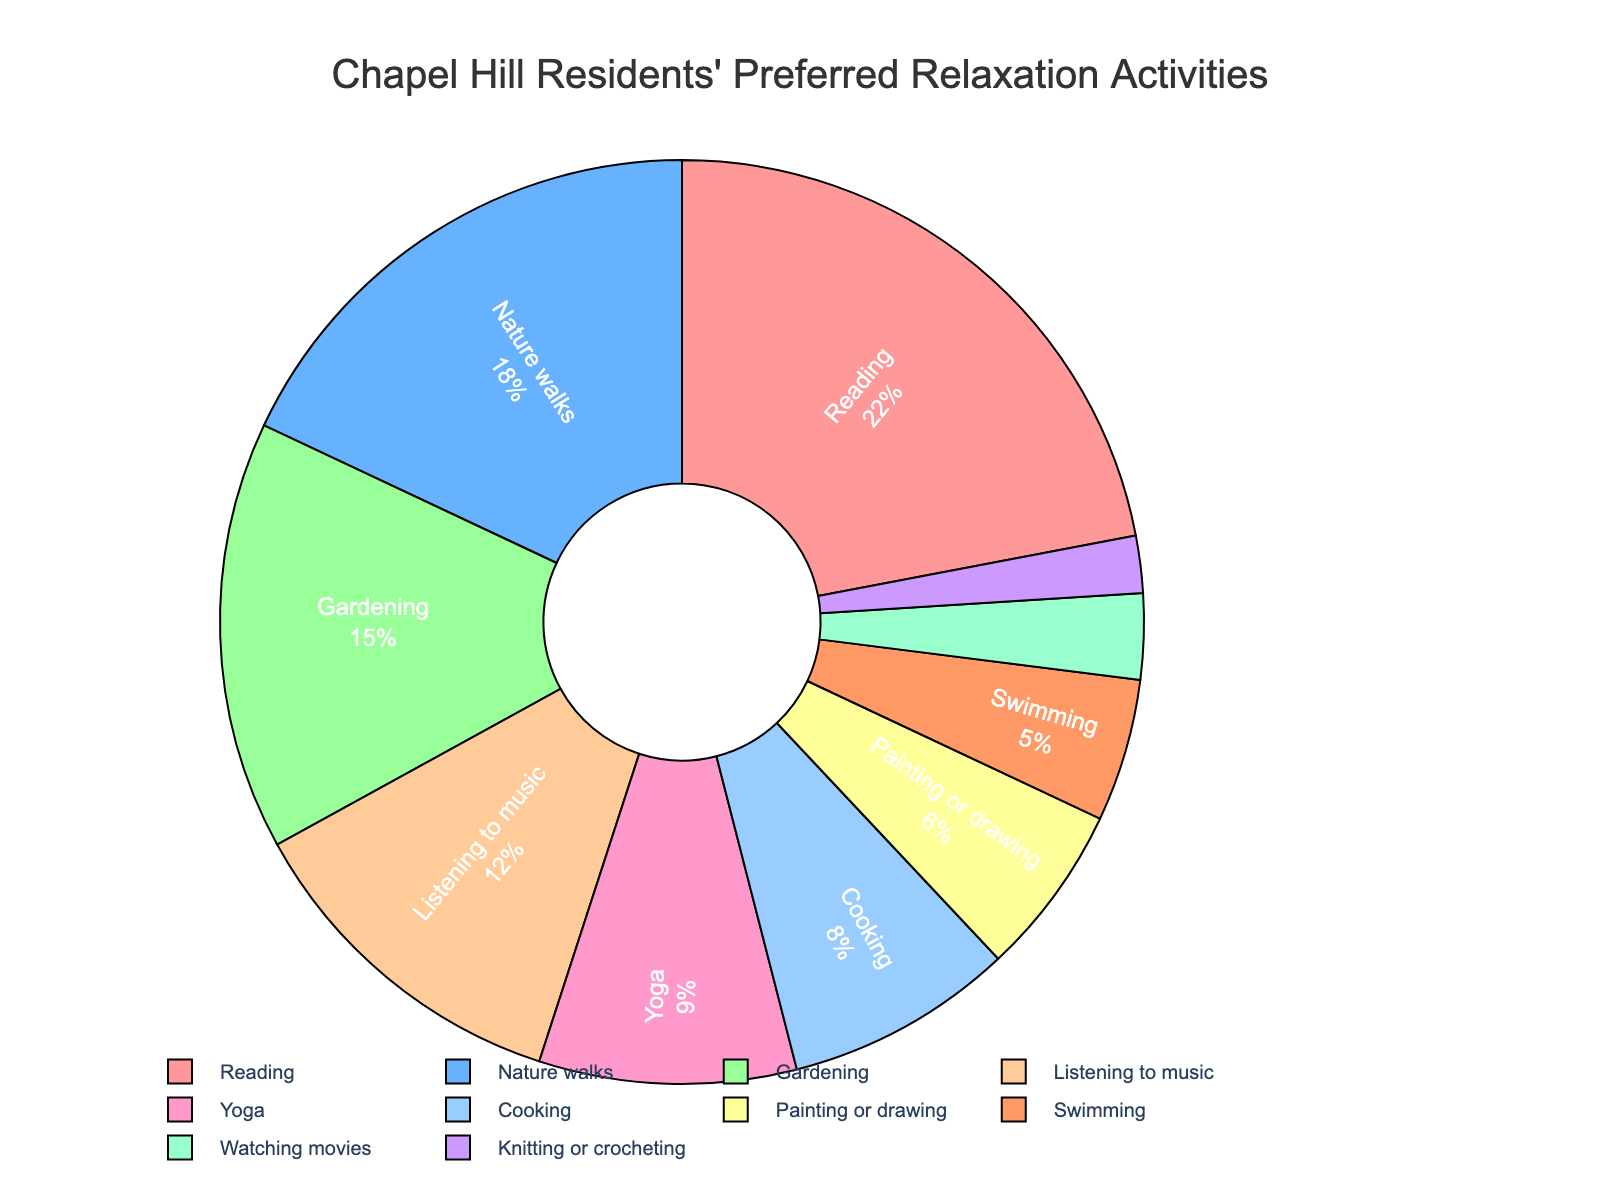Which activity is preferred by the highest percentage of Chapel Hill residents? By examining the pie chart, the activity with the largest slice represents the highest preference. According to the figure, reading has the largest slice.
Answer: Reading What is the total percentage of residents who prefer gardening or cooking? By adding the percentages for gardening (15%) and cooking (8%), we get 15 + 8 = 23%.
Answer: 23% Which activity is the least preferred by Chapel Hill residents? Examining the smallest slice of the pie chart shows the least preferred activity. The smallest slice is for knitting or crocheting at 2%.
Answer: Knitting or crocheting How does the percentage of residents who prefer nature walks compare to those who prefer listening to music? By looking at the pie chart, nature walks are at 18% and listening to music is at 12%. Comparing these, 18% is greater than 12%.
Answer: Nature walks What percentage of residents prefer activities involving physical movement, such as yoga and swimming combined? Adding the percentages for yoga (9%) and swimming (5%), we get 9 + 5 = 14%.
Answer: 14% Which activities are preferred by at least 10% of residents? The pie chart shows the slices for activities that meet or exceed 10%. These activities are reading (22%), nature walks (18%), gardening (15%), and listening to music (12%).
Answer: Reading, nature walks, gardening, listening to music What is the difference in percentage between the residents who enjoy painting or drawing and those who enjoy watching movies? Subtracting the percentage for watching movies (3%) from painting or drawing (6%), we get 6 - 3 = 3%.
Answer: 3% Is the total percentage of residents who prefer listening to music and knitting or crocheting less than those who prefer gardening? Adding the percentages for listening to music (12%) and knitting or crocheting (2%) gives 12 + 2 = 14%. Comparing this to gardening (15%), 14% is less than 15%.
Answer: Yes Which activity has a higher percentage: cooking or painting or drawing? Observing the pie chart, cooking is at 8%, and painting or drawing is at 6%. Therefore, cooking has a higher percentage.
Answer: Cooking How does the percentage for yoga compare to the combined percentages of knitting or crocheting and watching movies? Adding the percentages for knitting or crocheting (2%) and watching movies (3%) gives 2 + 3 = 5%. Yoga is at 9%, which is greater than 5%.
Answer: Yoga 